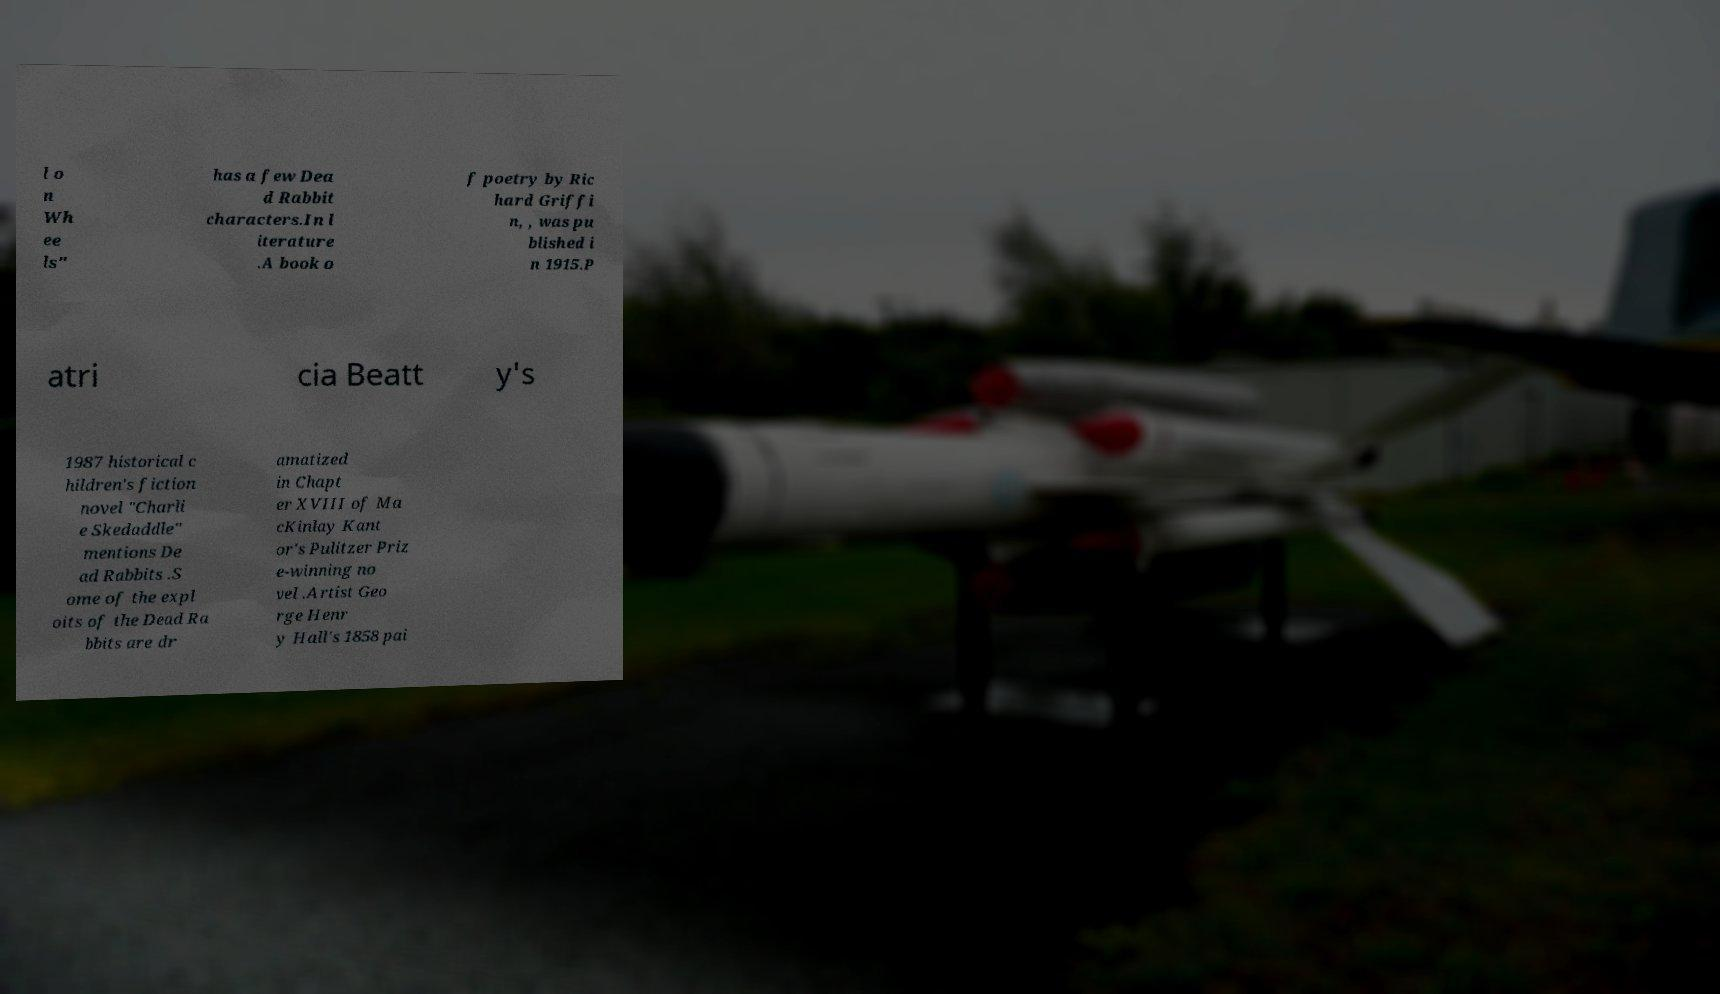What messages or text are displayed in this image? I need them in a readable, typed format. l o n Wh ee ls" has a few Dea d Rabbit characters.In l iterature .A book o f poetry by Ric hard Griffi n, , was pu blished i n 1915.P atri cia Beatt y's 1987 historical c hildren's fiction novel "Charli e Skedaddle" mentions De ad Rabbits .S ome of the expl oits of the Dead Ra bbits are dr amatized in Chapt er XVIII of Ma cKinlay Kant or's Pulitzer Priz e-winning no vel .Artist Geo rge Henr y Hall's 1858 pai 